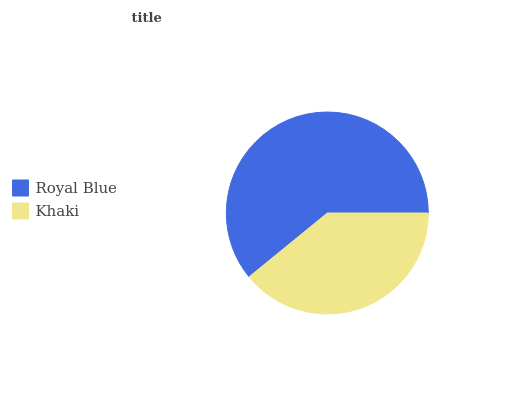Is Khaki the minimum?
Answer yes or no. Yes. Is Royal Blue the maximum?
Answer yes or no. Yes. Is Khaki the maximum?
Answer yes or no. No. Is Royal Blue greater than Khaki?
Answer yes or no. Yes. Is Khaki less than Royal Blue?
Answer yes or no. Yes. Is Khaki greater than Royal Blue?
Answer yes or no. No. Is Royal Blue less than Khaki?
Answer yes or no. No. Is Royal Blue the high median?
Answer yes or no. Yes. Is Khaki the low median?
Answer yes or no. Yes. Is Khaki the high median?
Answer yes or no. No. Is Royal Blue the low median?
Answer yes or no. No. 